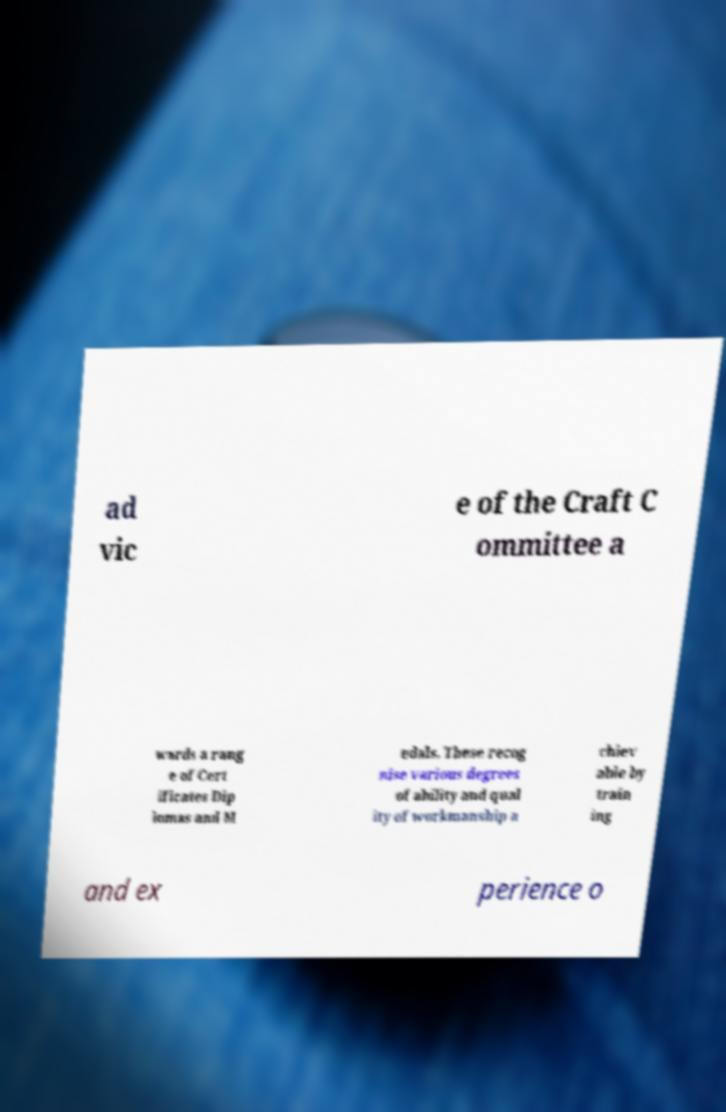I need the written content from this picture converted into text. Can you do that? ad vic e of the Craft C ommittee a wards a rang e of Cert ificates Dip lomas and M edals. These recog nise various degrees of ability and qual ity of workmanship a chiev able by train ing and ex perience o 